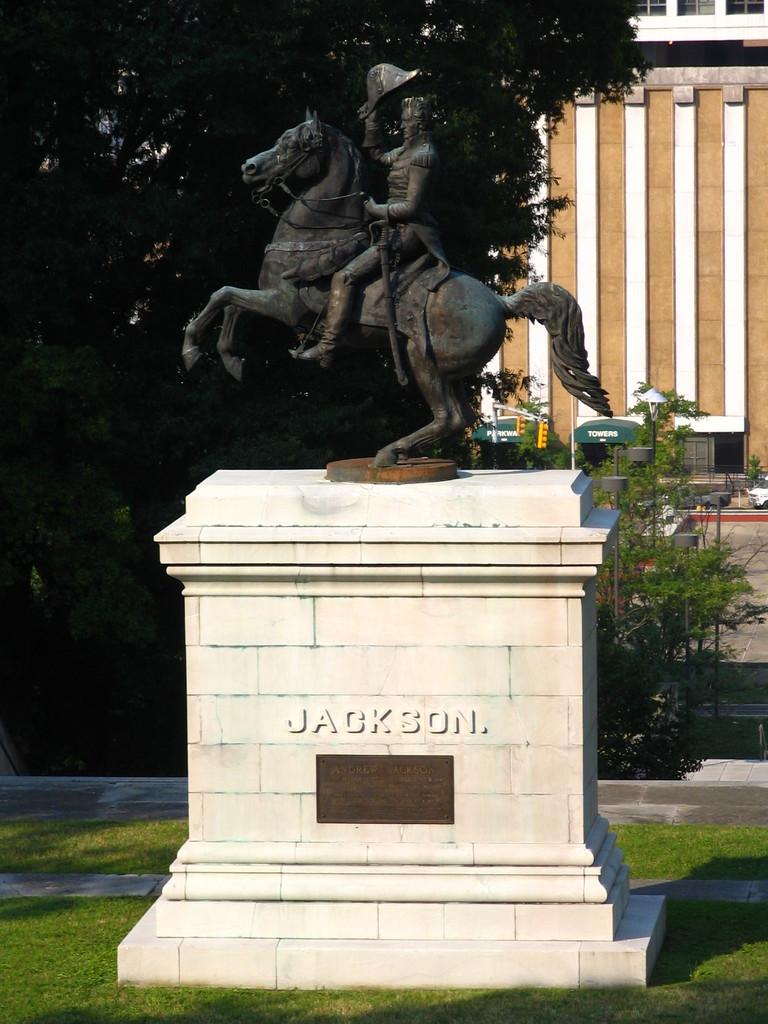What is the main subject in the center of the image? There is a statue in the center of the image. What is the statue placed on? The statue is on a memorial. What type of vegetation can be seen in the image? There is grass, plants, and trees visible in the image. What other structures can be seen in the image? There is a pole and a building in the image. What part of the statue is talking to the mother in the image? There is no mother or talking part of the statue present in the image; it is a statue on a memorial surrounded by vegetation and other structures. 